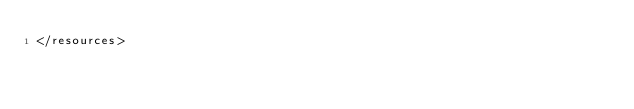<code> <loc_0><loc_0><loc_500><loc_500><_XML_></resources>
</code> 